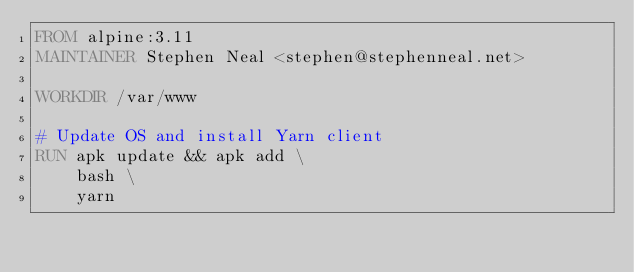<code> <loc_0><loc_0><loc_500><loc_500><_Dockerfile_>FROM alpine:3.11
MAINTAINER Stephen Neal <stephen@stephenneal.net>

WORKDIR /var/www

# Update OS and install Yarn client
RUN apk update && apk add \
    bash \
    yarn</code> 